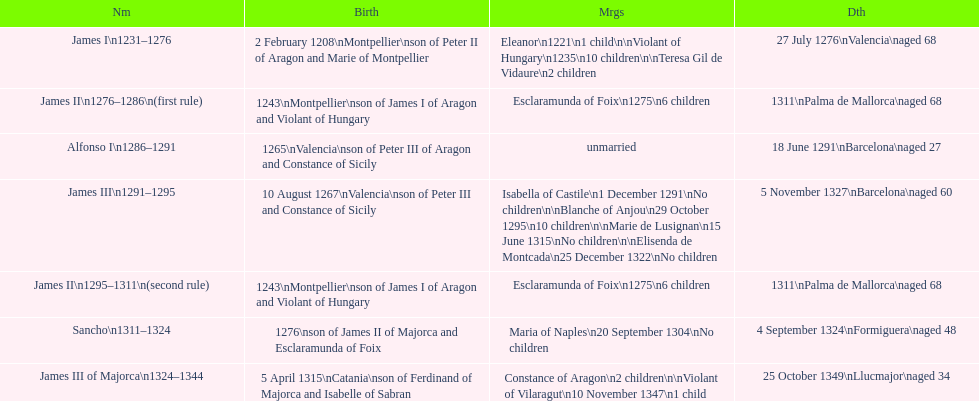Would you mind parsing the complete table? {'header': ['Nm', 'Birth', 'Mrgs', 'Dth'], 'rows': [['James I\\n1231–1276', '2 February 1208\\nMontpellier\\nson of Peter II of Aragon and Marie of Montpellier', 'Eleanor\\n1221\\n1 child\\n\\nViolant of Hungary\\n1235\\n10 children\\n\\nTeresa Gil de Vidaure\\n2 children', '27 July 1276\\nValencia\\naged 68'], ['James II\\n1276–1286\\n(first rule)', '1243\\nMontpellier\\nson of James I of Aragon and Violant of Hungary', 'Esclaramunda of Foix\\n1275\\n6 children', '1311\\nPalma de Mallorca\\naged 68'], ['Alfonso I\\n1286–1291', '1265\\nValencia\\nson of Peter III of Aragon and Constance of Sicily', 'unmarried', '18 June 1291\\nBarcelona\\naged 27'], ['James III\\n1291–1295', '10 August 1267\\nValencia\\nson of Peter III and Constance of Sicily', 'Isabella of Castile\\n1 December 1291\\nNo children\\n\\nBlanche of Anjou\\n29 October 1295\\n10 children\\n\\nMarie de Lusignan\\n15 June 1315\\nNo children\\n\\nElisenda de Montcada\\n25 December 1322\\nNo children', '5 November 1327\\nBarcelona\\naged 60'], ['James II\\n1295–1311\\n(second rule)', '1243\\nMontpellier\\nson of James I of Aragon and Violant of Hungary', 'Esclaramunda of Foix\\n1275\\n6 children', '1311\\nPalma de Mallorca\\naged 68'], ['Sancho\\n1311–1324', '1276\\nson of James II of Majorca and Esclaramunda of Foix', 'Maria of Naples\\n20 September 1304\\nNo children', '4 September 1324\\nFormiguera\\naged 48'], ['James III of Majorca\\n1324–1344', '5 April 1315\\nCatania\\nson of Ferdinand of Majorca and Isabelle of Sabran', 'Constance of Aragon\\n2 children\\n\\nViolant of Vilaragut\\n10 November 1347\\n1 child', '25 October 1349\\nLlucmajor\\naged 34']]} Which monarch had the most marriages? James III 1291-1295. 